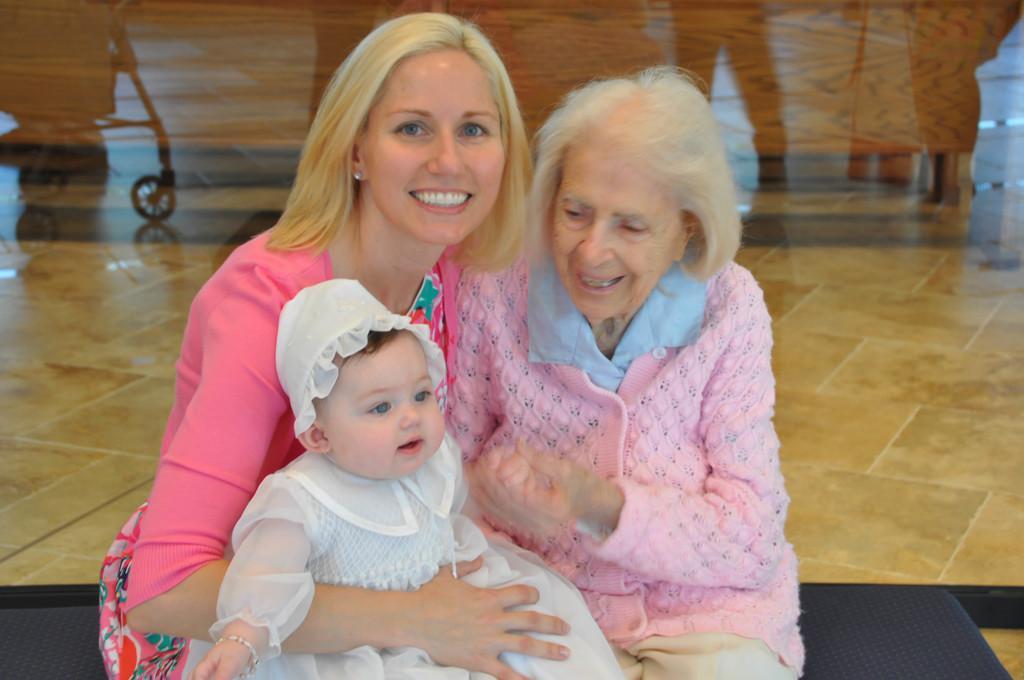How would you summarize this image in a sentence or two? In the image few people are sitting and smiling. 